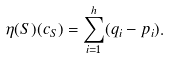<formula> <loc_0><loc_0><loc_500><loc_500>\eta ( S ) ( c _ { S } ) = \sum _ { i = 1 } ^ { h } ( q _ { i } - p _ { i } ) .</formula> 